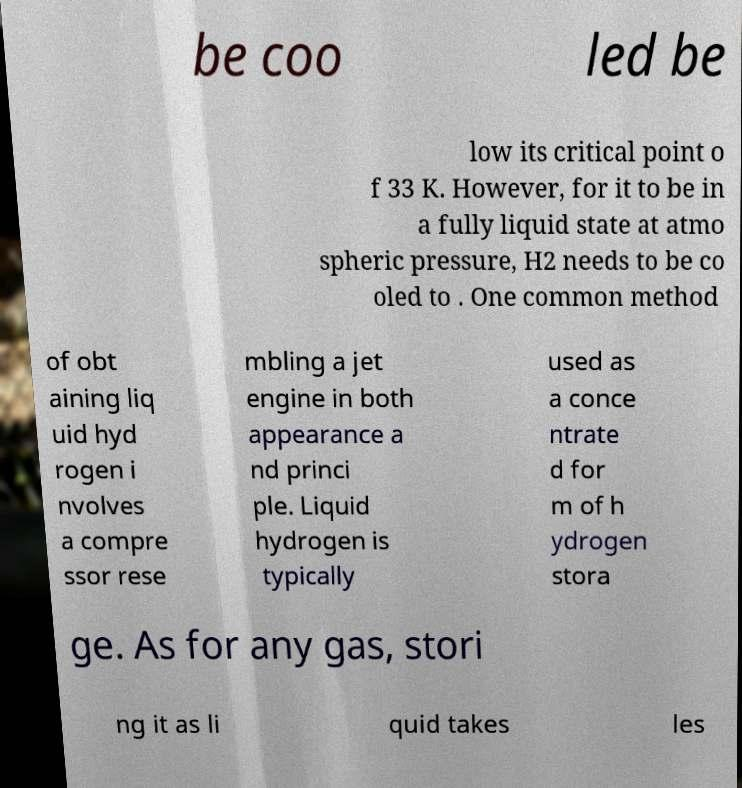For documentation purposes, I need the text within this image transcribed. Could you provide that? be coo led be low its critical point o f 33 K. However, for it to be in a fully liquid state at atmo spheric pressure, H2 needs to be co oled to . One common method of obt aining liq uid hyd rogen i nvolves a compre ssor rese mbling a jet engine in both appearance a nd princi ple. Liquid hydrogen is typically used as a conce ntrate d for m of h ydrogen stora ge. As for any gas, stori ng it as li quid takes les 